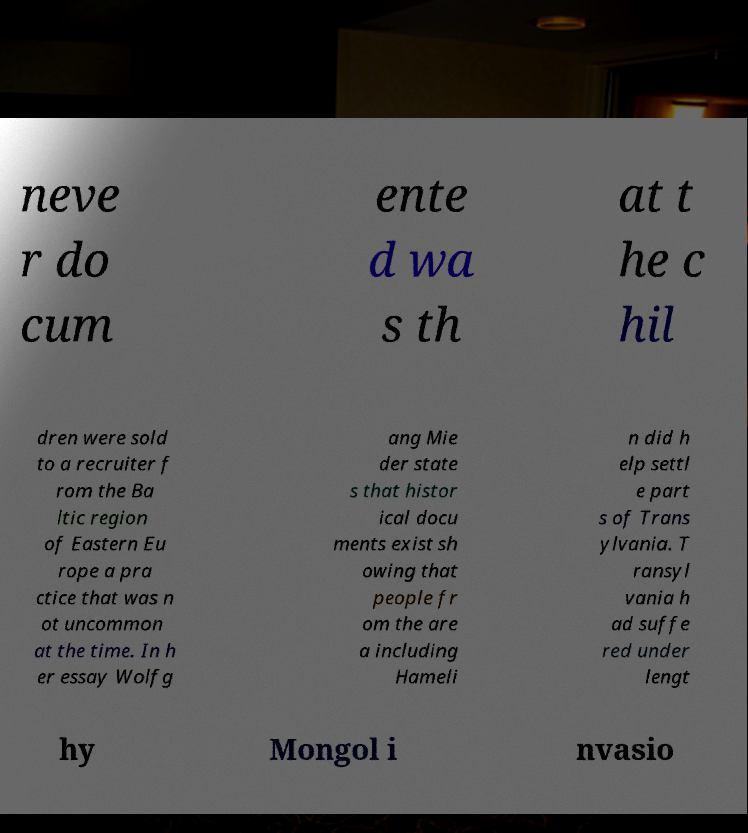Could you extract and type out the text from this image? neve r do cum ente d wa s th at t he c hil dren were sold to a recruiter f rom the Ba ltic region of Eastern Eu rope a pra ctice that was n ot uncommon at the time. In h er essay Wolfg ang Mie der state s that histor ical docu ments exist sh owing that people fr om the are a including Hameli n did h elp settl e part s of Trans ylvania. T ransyl vania h ad suffe red under lengt hy Mongol i nvasio 